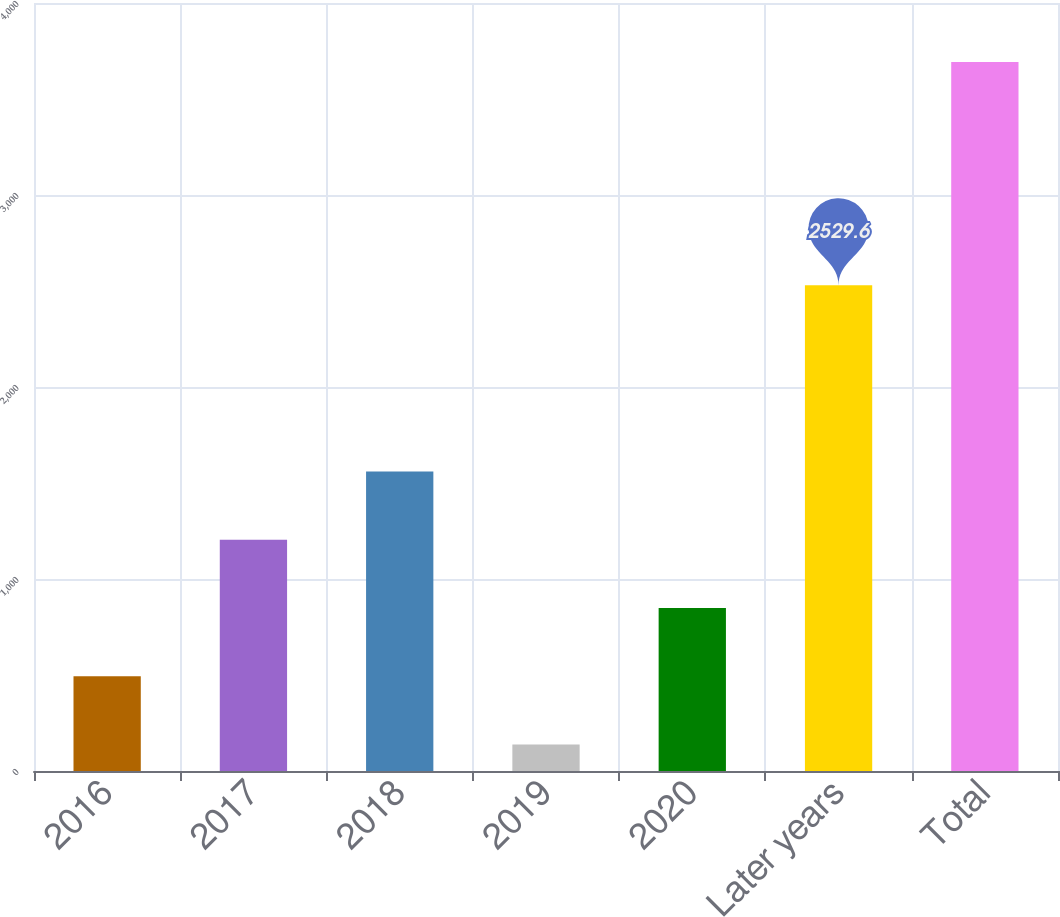Convert chart to OTSL. <chart><loc_0><loc_0><loc_500><loc_500><bar_chart><fcel>2016<fcel>2017<fcel>2018<fcel>2019<fcel>2020<fcel>Later years<fcel>Total<nl><fcel>493.8<fcel>1204.8<fcel>1560.3<fcel>138.3<fcel>849.3<fcel>2529.6<fcel>3693.3<nl></chart> 